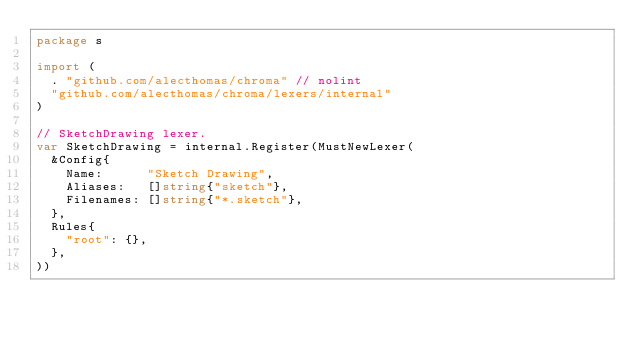<code> <loc_0><loc_0><loc_500><loc_500><_Go_>package s

import (
	. "github.com/alecthomas/chroma" // nolint
	"github.com/alecthomas/chroma/lexers/internal"
)

// SketchDrawing lexer.
var SketchDrawing = internal.Register(MustNewLexer(
	&Config{
		Name:      "Sketch Drawing",
		Aliases:   []string{"sketch"},
		Filenames: []string{"*.sketch"},
	},
	Rules{
		"root": {},
	},
))
</code> 